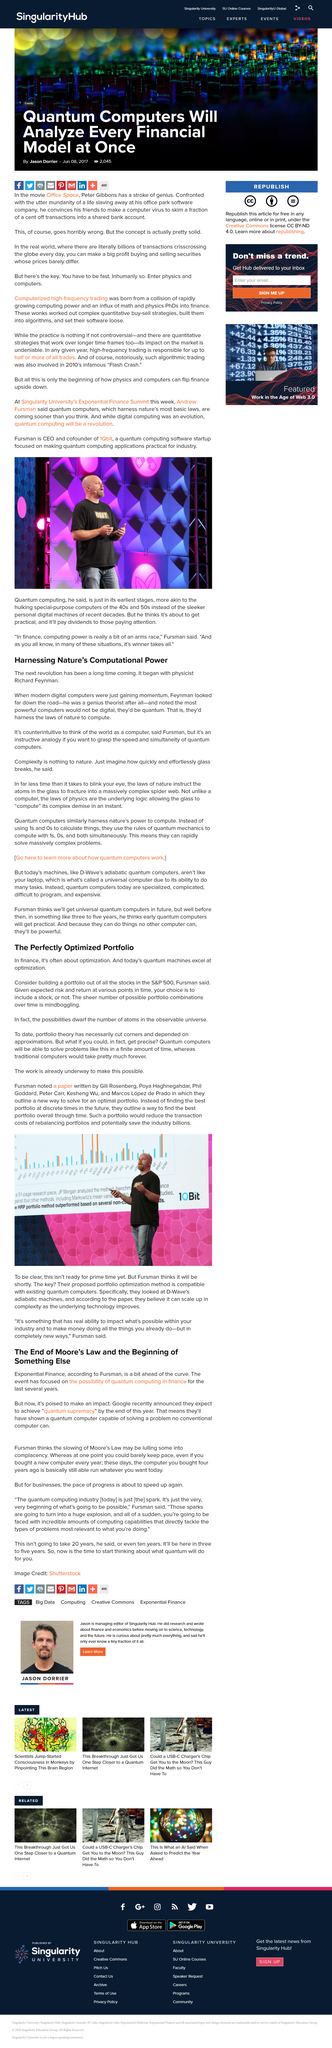Give some essential details in this illustration. The article is based on Fursman's opinion. The next revolution was started by physicist Richard Feynman. The number of possible portfolio combinations over time is so vast that it greatly exceeds the number of atoms in the observable universe. A quantum computer, as defined by Richard Freeman, is a computer that utilizes the laws of nature to perform computations. This article refers to Moore's Law, which is a well-known legal principle in the field of technology. 